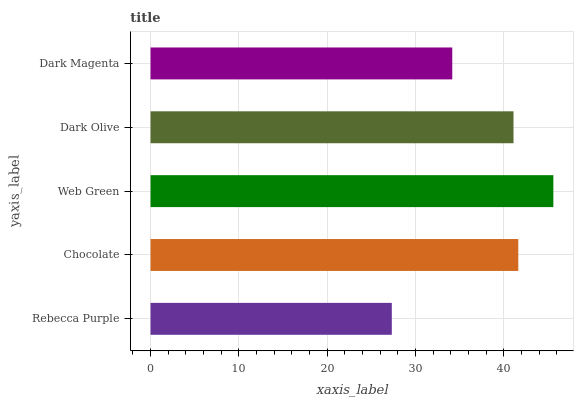Is Rebecca Purple the minimum?
Answer yes or no. Yes. Is Web Green the maximum?
Answer yes or no. Yes. Is Chocolate the minimum?
Answer yes or no. No. Is Chocolate the maximum?
Answer yes or no. No. Is Chocolate greater than Rebecca Purple?
Answer yes or no. Yes. Is Rebecca Purple less than Chocolate?
Answer yes or no. Yes. Is Rebecca Purple greater than Chocolate?
Answer yes or no. No. Is Chocolate less than Rebecca Purple?
Answer yes or no. No. Is Dark Olive the high median?
Answer yes or no. Yes. Is Dark Olive the low median?
Answer yes or no. Yes. Is Web Green the high median?
Answer yes or no. No. Is Web Green the low median?
Answer yes or no. No. 